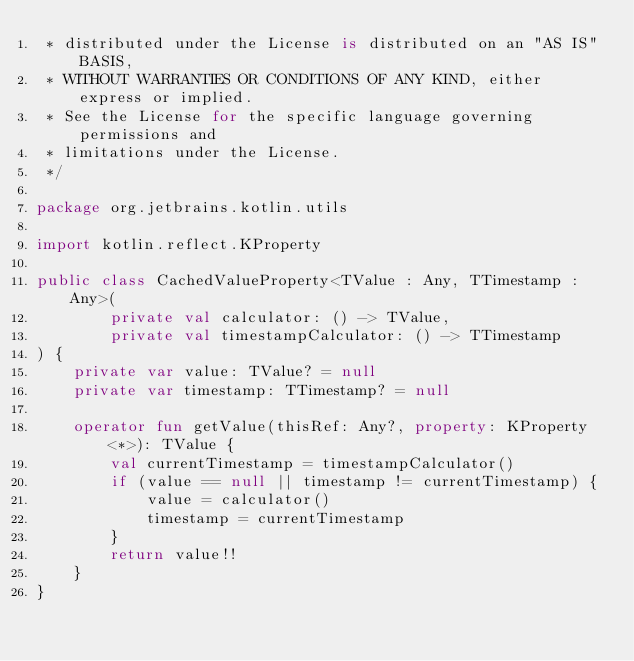<code> <loc_0><loc_0><loc_500><loc_500><_Kotlin_> * distributed under the License is distributed on an "AS IS" BASIS,
 * WITHOUT WARRANTIES OR CONDITIONS OF ANY KIND, either express or implied.
 * See the License for the specific language governing permissions and
 * limitations under the License.
 */

package org.jetbrains.kotlin.utils

import kotlin.reflect.KProperty

public class CachedValueProperty<TValue : Any, TTimestamp : Any>(
        private val calculator: () -> TValue,
        private val timestampCalculator: () -> TTimestamp
) {
    private var value: TValue? = null
    private var timestamp: TTimestamp? = null

    operator fun getValue(thisRef: Any?, property: KProperty<*>): TValue {
        val currentTimestamp = timestampCalculator()
        if (value == null || timestamp != currentTimestamp) {
            value = calculator()
            timestamp = currentTimestamp
        }
        return value!!
    }
}
</code> 